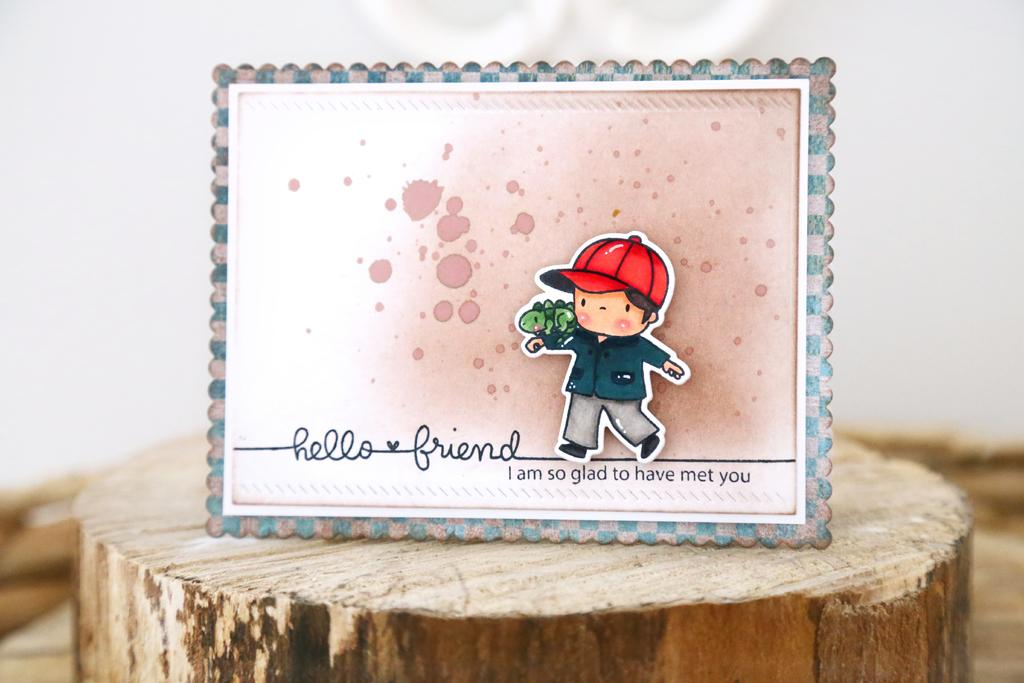What is the main subject of the image? The main subject of the image is a greeting. What material is the greeting placed on? The greeting is placed on wood. Where is the greeting located in the image? The greeting is located in the center of the image. What type of meat can be seen in the image? There is no meat present in the image. 